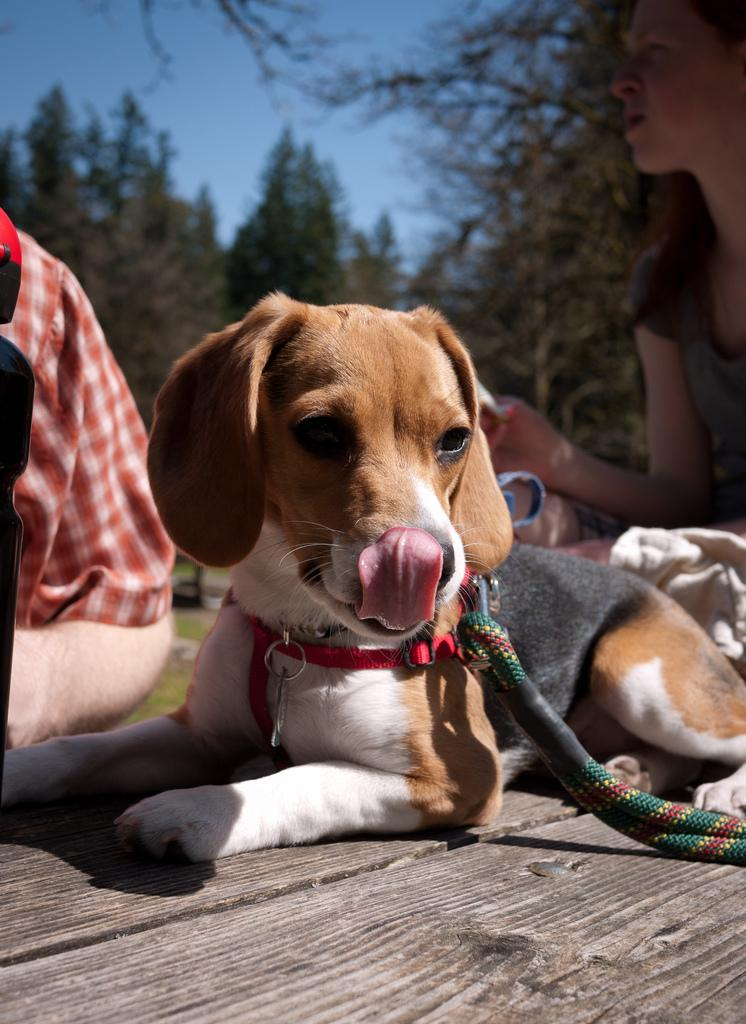What animal is present in the image? There is a dog in the image. What colors can be seen on the dog? The dog has black, brown, and white colors. What is the dog standing on in the image? The dog is on a black surface. What can be seen in the background of the image? There are people and trees visible in the background. What color is the sky in the image? The sky is blue in the image. How many pizzas are being eaten by the dog in the image? There are no pizzas present in the image; it features a dog on a black surface with a blue sky in the background. What type of spark can be seen coming from the dog's eyes in the image? There is no spark visible in the dog's eyes in the image. 